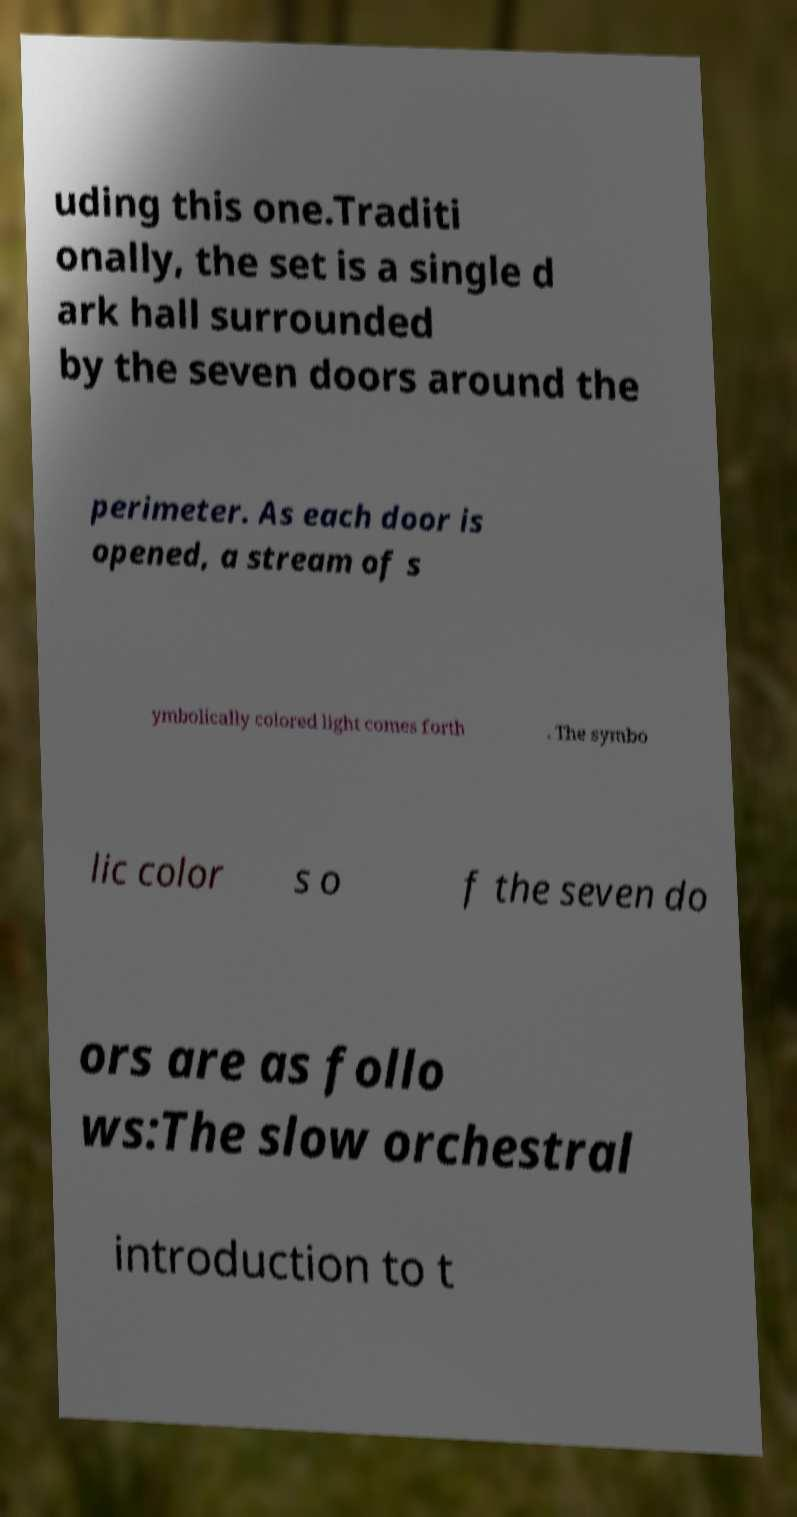Could you extract and type out the text from this image? uding this one.Traditi onally, the set is a single d ark hall surrounded by the seven doors around the perimeter. As each door is opened, a stream of s ymbolically colored light comes forth . The symbo lic color s o f the seven do ors are as follo ws:The slow orchestral introduction to t 